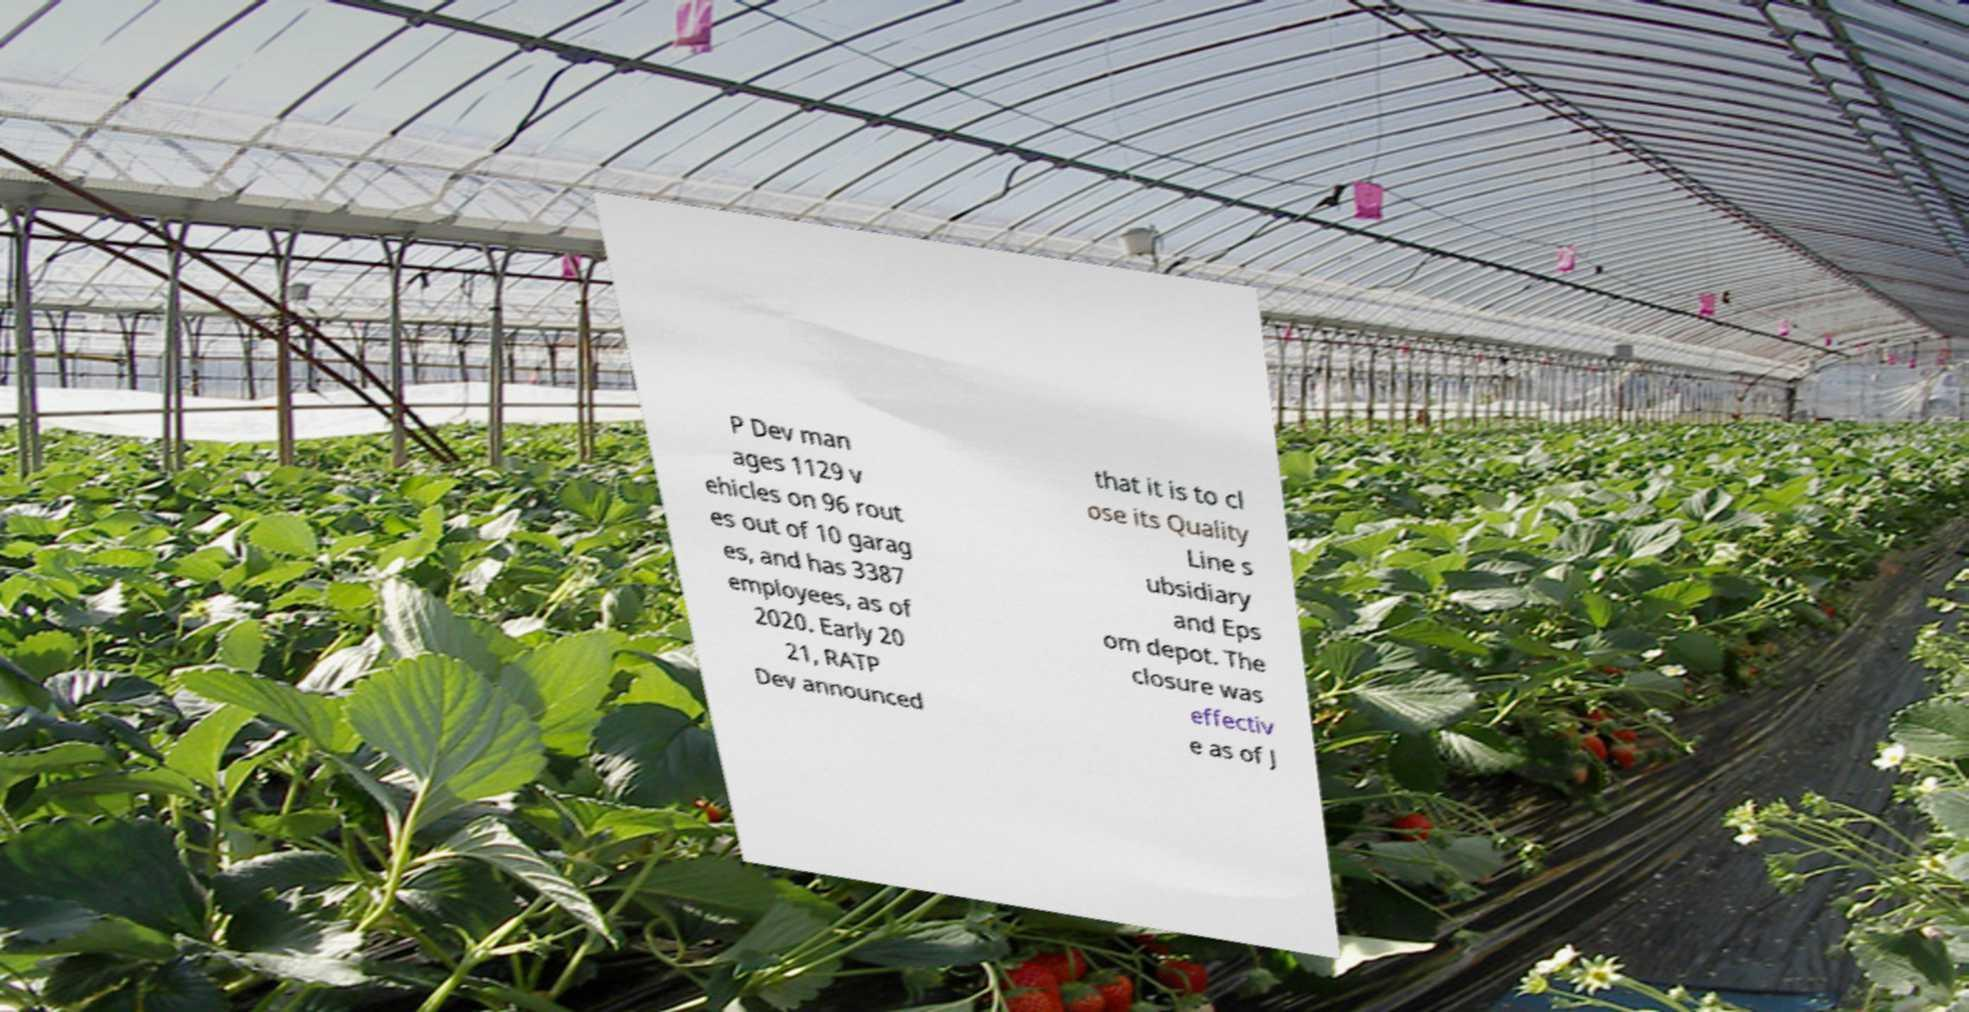Please read and relay the text visible in this image. What does it say? P Dev man ages 1129 v ehicles on 96 rout es out of 10 garag es, and has 3387 employees, as of 2020. Early 20 21, RATP Dev announced that it is to cl ose its Quality Line s ubsidiary and Eps om depot. The closure was effectiv e as of J 